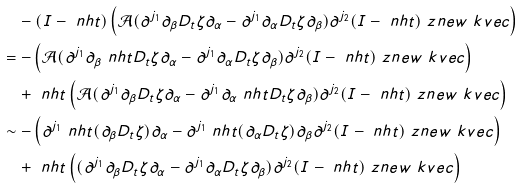<formula> <loc_0><loc_0><loc_500><loc_500>& \quad - ( I - \ n h t ) \left ( \mathcal { A } ( \partial ^ { j _ { 1 } } \partial _ { \beta } D _ { t } \zeta \partial _ { \alpha } - \partial ^ { j _ { 1 } } \partial _ { \alpha } D _ { t } \zeta \partial _ { \beta } ) \partial ^ { j _ { 2 } } ( I - \ n h t ) \ z n e w \ k v e c \right ) \\ & = - \left ( \mathcal { A } ( \partial ^ { j _ { 1 } } \partial _ { \beta } \ n h t D _ { t } \zeta \partial _ { \alpha } - \partial ^ { j _ { 1 } } \partial _ { \alpha } D _ { t } \zeta \partial _ { \beta } ) \partial ^ { j _ { 2 } } ( I - \ n h t ) \ z n e w \ k v e c \right ) \\ & \quad + \ n h t \left ( \mathcal { A } ( \partial ^ { j _ { 1 } } \partial _ { \beta } D _ { t } \zeta \partial _ { \alpha } - \partial ^ { j _ { 1 } } \partial _ { \alpha } \ n h t D _ { t } \zeta \partial _ { \beta } ) \partial ^ { j _ { 2 } } ( I - \ n h t ) \ z n e w \ k v e c \right ) \\ & \sim - \left ( \partial ^ { j _ { 1 } } \ n h t ( \partial _ { \beta } D _ { t } \zeta ) \partial _ { \alpha } - \partial ^ { j _ { 1 } } \ n h t ( \partial _ { \alpha } D _ { t } \zeta ) \partial _ { \beta } \partial ^ { j _ { 2 } } ( I - \ n h t ) \ z n e w \ k v e c \right ) \\ & \quad + \ n h t \left ( ( \partial ^ { j _ { 1 } } \partial _ { \beta } D _ { t } \zeta \partial _ { \alpha } - \partial ^ { j _ { 1 } } \partial _ { \alpha } D _ { t } \zeta \partial _ { \beta } ) \partial ^ { j _ { 2 } } ( I - \ n h t ) \ z n e w \ k v e c \right )</formula> 